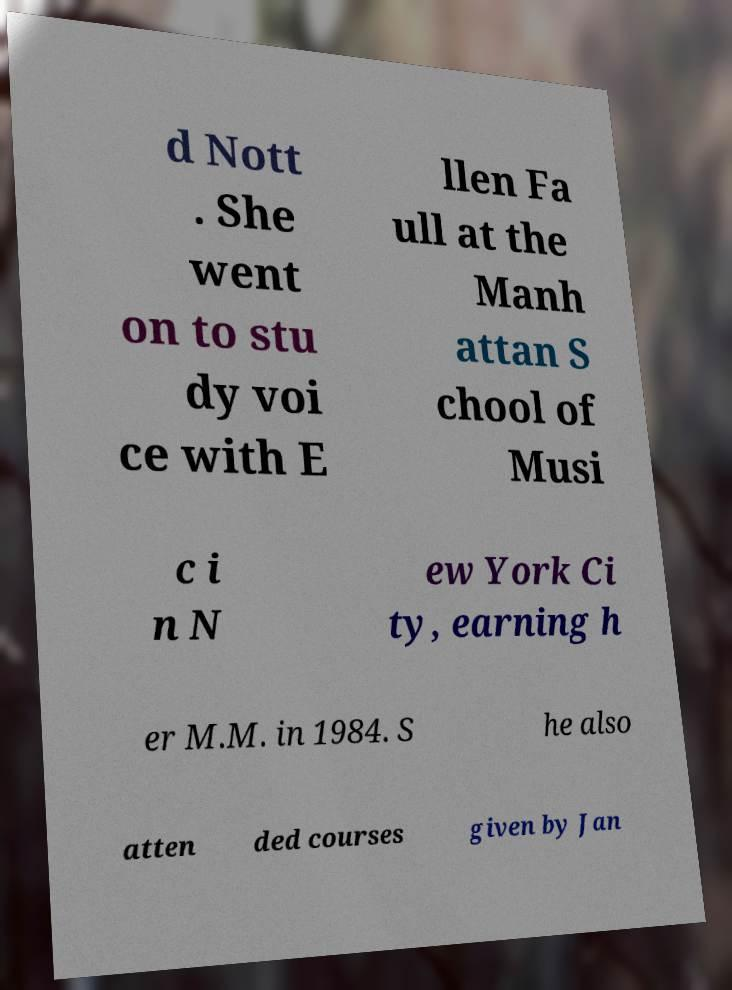I need the written content from this picture converted into text. Can you do that? d Nott . She went on to stu dy voi ce with E llen Fa ull at the Manh attan S chool of Musi c i n N ew York Ci ty, earning h er M.M. in 1984. S he also atten ded courses given by Jan 